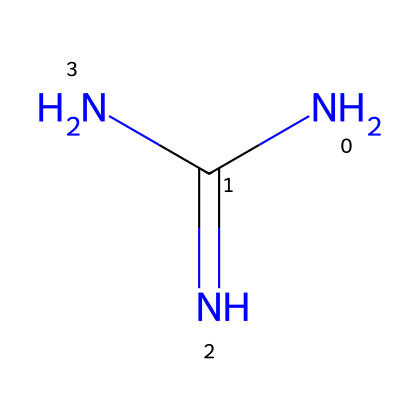What is the name of this chemical? The chemical is composed of a carbon (C), nitrogen (N), and additional nitrogen atoms in its structure, which corresponds to the common chemical known as guanidine.
Answer: guanidine How many nitrogen atoms are present in this structure? By examining the SMILES representation, there are three nitrogen atoms indicated by 'N' in the structure.
Answer: three What type of chemical is guanidine classified as? Guanidine is primarily classified as an organic base due to the presence of multiple nitrogen atoms which can accept protons.
Answer: organic base What is the total number of atoms in the guanidine molecule? The molecular composition includes one carbon atom and four nitrogen atoms, resulting in a total of five atoms in the chemical.
Answer: five What properties might guanidine contribute to pool cleaning products? Guanidine, as a strong base, can increase the pH and assist in breaking down organic matter in water, making it effective for cleaning.
Answer: strong base Is guanidine considered a superbase? Guanidine is recognized for its high basicity, which qualifies it as a superbase, forming stable compounds in various reactions.
Answer: superbase 